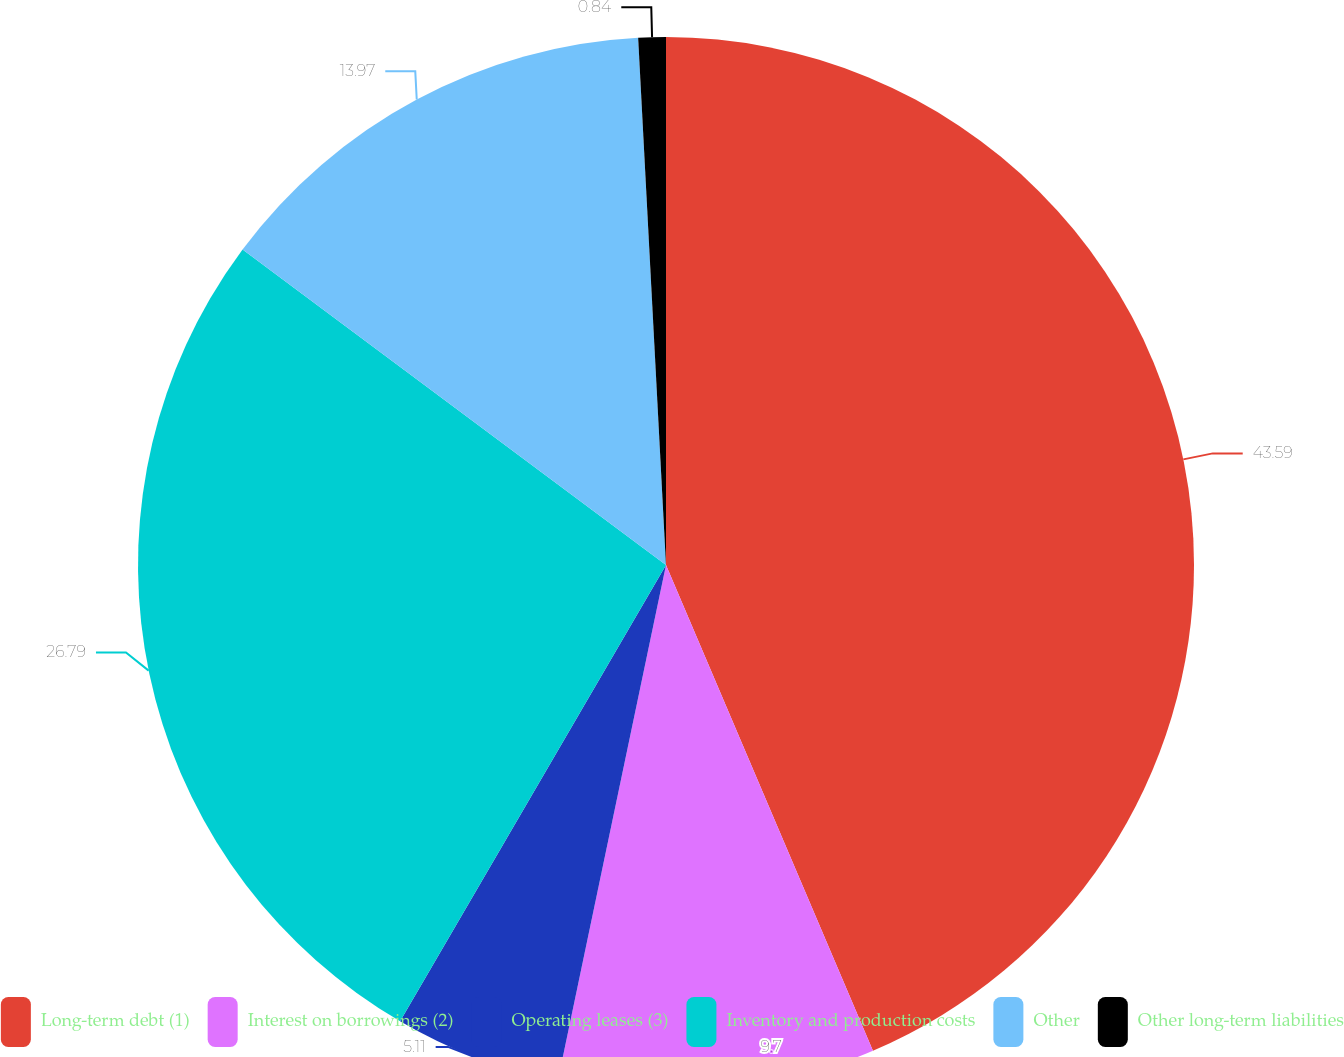Convert chart to OTSL. <chart><loc_0><loc_0><loc_500><loc_500><pie_chart><fcel>Long-term debt (1)<fcel>Interest on borrowings (2)<fcel>Operating leases (3)<fcel>Inventory and production costs<fcel>Other<fcel>Other long-term liabilities<nl><fcel>43.59%<fcel>9.7%<fcel>5.11%<fcel>26.79%<fcel>13.97%<fcel>0.84%<nl></chart> 